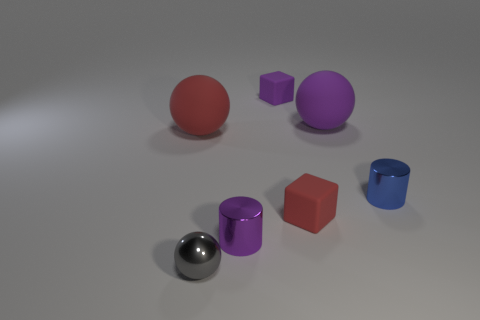Add 2 small red balls. How many objects exist? 9 Subtract all balls. How many objects are left? 4 Add 5 gray shiny objects. How many gray shiny objects exist? 6 Subtract 0 yellow balls. How many objects are left? 7 Subtract all small blocks. Subtract all tiny purple matte things. How many objects are left? 4 Add 6 tiny metallic balls. How many tiny metallic balls are left? 7 